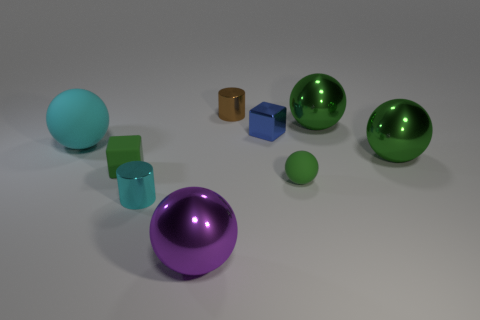There is a big matte object that is the same shape as the purple shiny thing; what is its color?
Your response must be concise. Cyan. Is the number of large green metallic spheres that are behind the big cyan ball greater than the number of cylinders?
Ensure brevity in your answer.  No. There is a big rubber thing; is it the same shape as the green object that is behind the large rubber sphere?
Your answer should be compact. Yes. Is there anything else that has the same size as the blue block?
Offer a very short reply. Yes. What is the size of the cyan thing that is the same shape as the small brown shiny object?
Your response must be concise. Small. Are there more big things than small blue cubes?
Offer a terse response. Yes. Does the blue object have the same shape as the brown thing?
Ensure brevity in your answer.  No. There is a big ball on the left side of the shiny sphere to the left of the green rubber ball; what is it made of?
Ensure brevity in your answer.  Rubber. There is a tiny thing that is the same color as the small sphere; what material is it?
Keep it short and to the point. Rubber. Is the brown metallic object the same size as the cyan metal cylinder?
Offer a very short reply. Yes. 